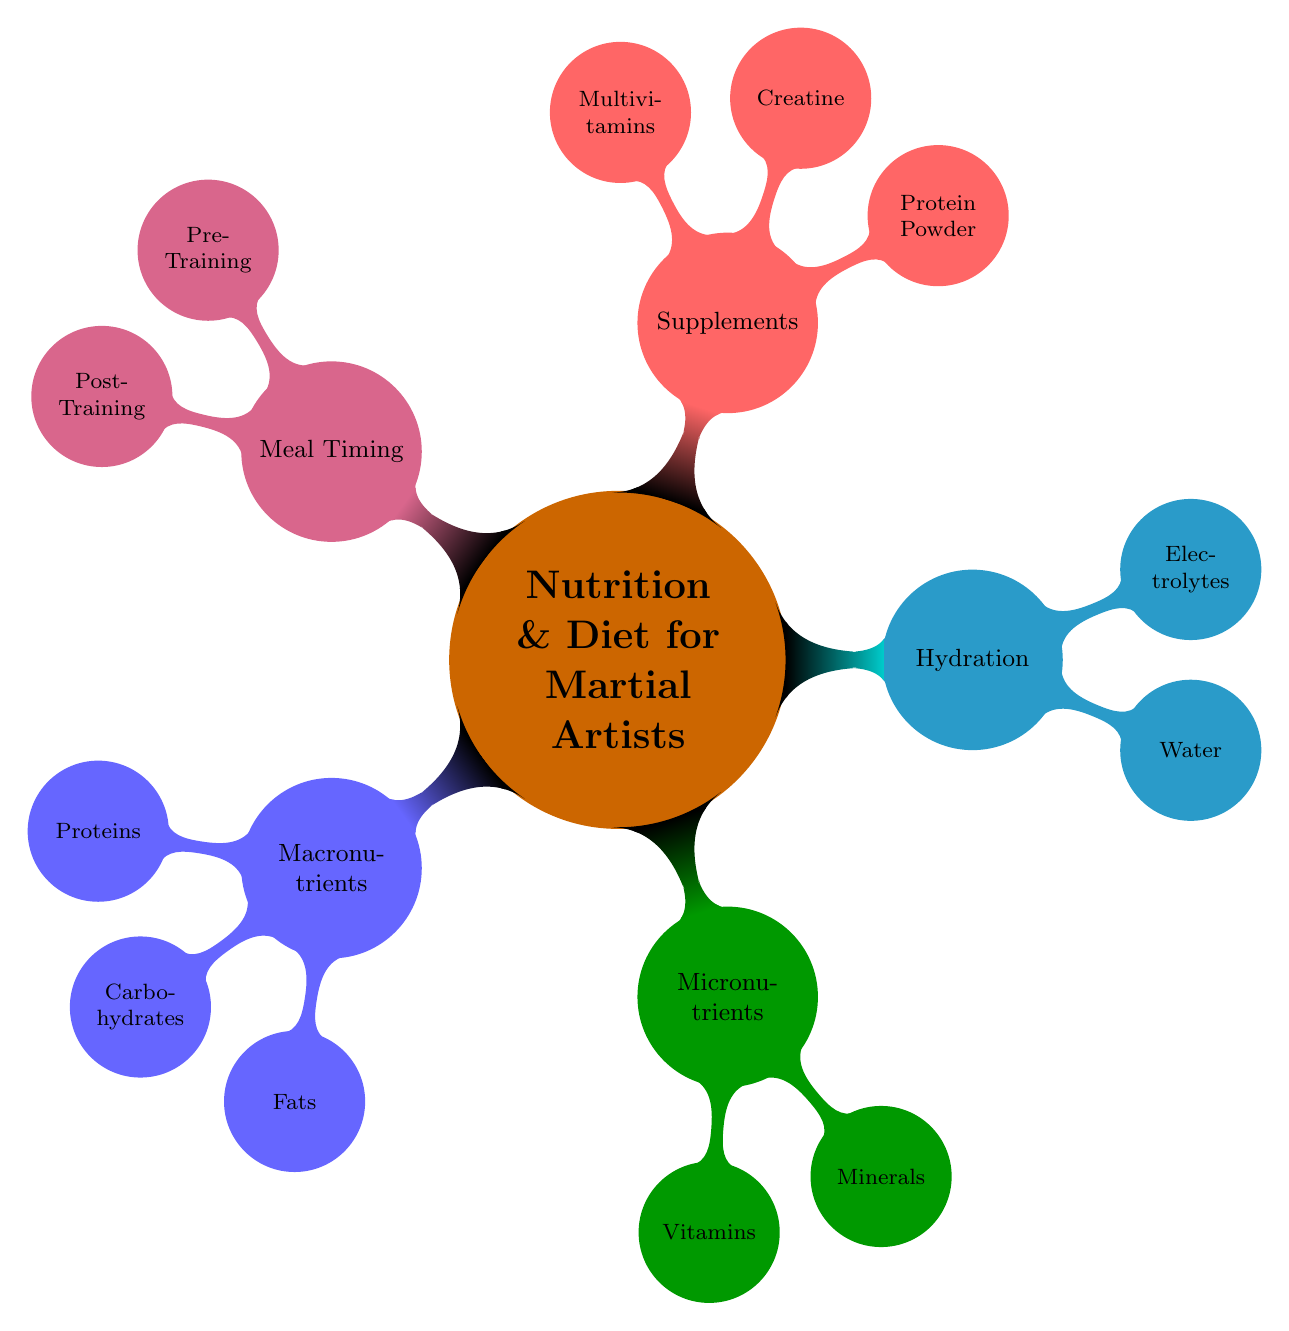What are the three main macronutrients listed? The diagram identifies three main macronutrients in the "Macronutrients" node: Proteins, Carbohydrates, and Fats.
Answer: Proteins, Carbohydrates, Fats Which vitamin is associated with citrus fruits? Under the "Micronutrients" section, the specific vitamin associated with citrus fruits is Vitamin C.
Answer: Vitamin C How many different types of hydration elements are there? The "Hydration" node contains two types: Water and Electrolytes. Thus, there are two elements listed under hydration.
Answer: 2 What is a recommended post-training meal component? In the "Post-Training" section, one of the meal components listed is a Protein-Rich Meal.
Answer: Protein-Rich Meal Which type of protein powder is mentioned? Under "Supplements," a specific type of protein powder mentioned is Whey Protein.
Answer: Whey Protein What is the relationship between Pre-Training and hydration? The "Pre-Training" node suggests Hydration as one of its components. This indicates that staying hydrated is important before training.
Answer: Hydration What category includes lean meats and spinach? Lean meats and spinach are mentioned under the "Minerals" segment as sources of Iron, which categorizes them under Micronutrients.
Answer: Minerals How many child nodes does "Supplements" have? The "Supplements" node has three child nodes: Protein Powder, Creatine, and Multivitamins, indicating there are three specific supplements listed.
Answer: 3 Which carbohydrates are recommended for martial artists? Within the "Carbohydrates" child node under "Macronutrients," specific examples include Brown Rice, Quinoa, Sweet Potatoes, and Oats.
Answer: Brown Rice, Quinoa, Sweet Potatoes, Oats 